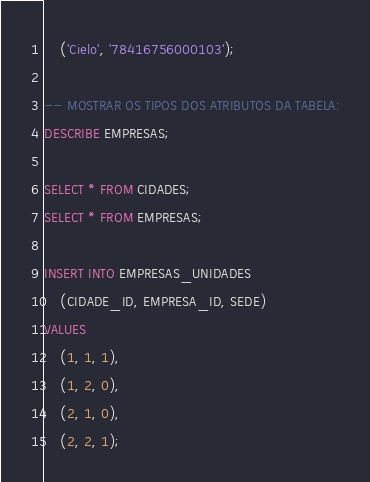Convert code to text. <code><loc_0><loc_0><loc_500><loc_500><_SQL_>    ('Cielo', '78416756000103');
    
-- MOSTRAR OS TIPOS DOS ATRIBUTOS DA TABELA:
DESCRIBE EMPRESAS;

SELECT * FROM CIDADES;
SELECT * FROM EMPRESAS;

INSERT INTO EMPRESAS_UNIDADES
	(CIDADE_ID, EMPRESA_ID, SEDE)
VALUES
	(1, 1, 1),
	(1, 2, 0),
	(2, 1, 0),
	(2, 2, 1);</code> 